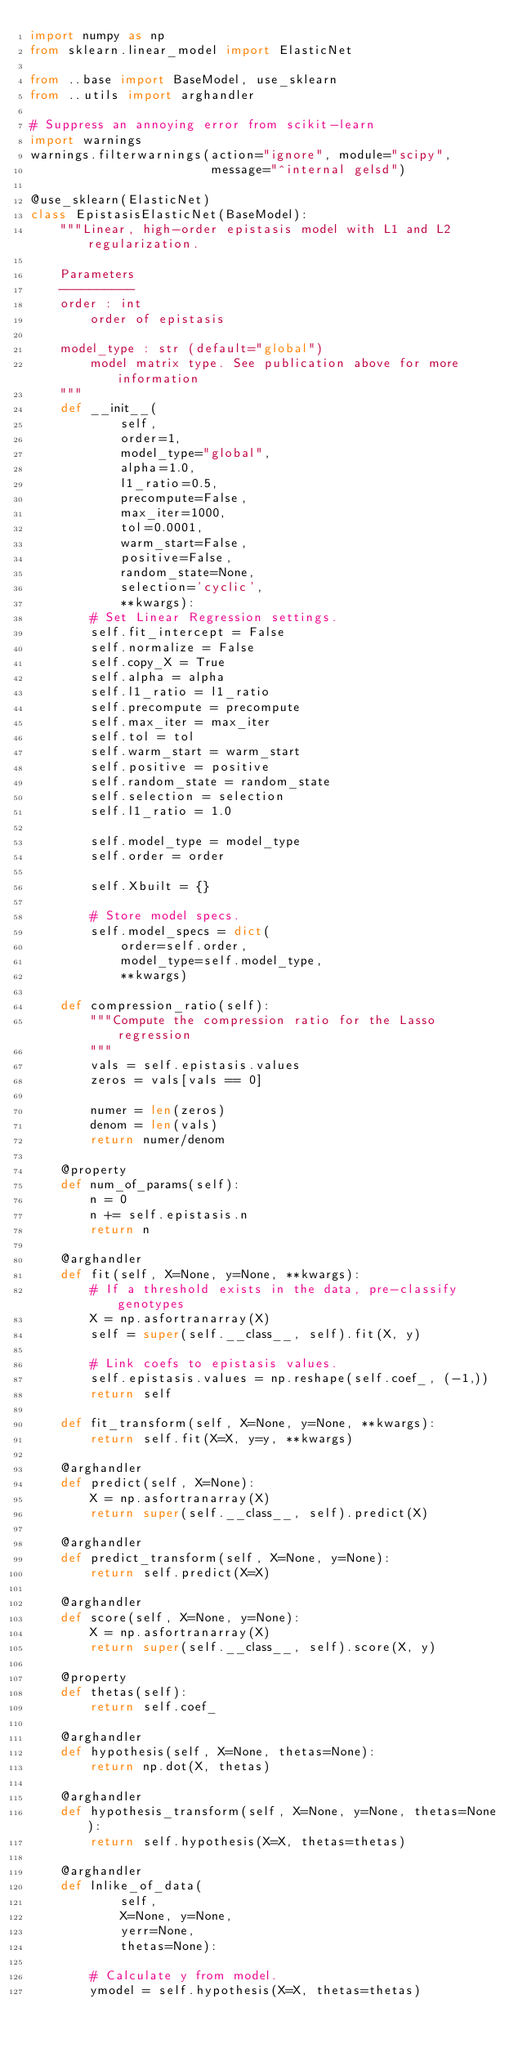<code> <loc_0><loc_0><loc_500><loc_500><_Python_>import numpy as np
from sklearn.linear_model import ElasticNet

from ..base import BaseModel, use_sklearn
from ..utils import arghandler

# Suppress an annoying error from scikit-learn
import warnings
warnings.filterwarnings(action="ignore", module="scipy",
                        message="^internal gelsd")

@use_sklearn(ElasticNet)
class EpistasisElasticNet(BaseModel):
    """Linear, high-order epistasis model with L1 and L2 regularization.

    Parameters
    ----------
    order : int
        order of epistasis

    model_type : str (default="global")
        model matrix type. See publication above for more information
    """
    def __init__(
            self,
            order=1,
            model_type="global",
            alpha=1.0,
            l1_ratio=0.5,
            precompute=False,
            max_iter=1000,
            tol=0.0001,
            warm_start=False,
            positive=False,
            random_state=None,
            selection='cyclic',
            **kwargs):
        # Set Linear Regression settings.
        self.fit_intercept = False
        self.normalize = False
        self.copy_X = True
        self.alpha = alpha
        self.l1_ratio = l1_ratio
        self.precompute = precompute
        self.max_iter = max_iter
        self.tol = tol
        self.warm_start = warm_start
        self.positive = positive
        self.random_state = random_state
        self.selection = selection
        self.l1_ratio = 1.0

        self.model_type = model_type
        self.order = order

        self.Xbuilt = {}

        # Store model specs.
        self.model_specs = dict(
            order=self.order,
            model_type=self.model_type,
            **kwargs)

    def compression_ratio(self):
        """Compute the compression ratio for the Lasso regression
        """
        vals = self.epistasis.values
        zeros = vals[vals == 0]

        numer = len(zeros)
        denom = len(vals)
        return numer/denom

    @property
    def num_of_params(self):
        n = 0
        n += self.epistasis.n
        return n

    @arghandler
    def fit(self, X=None, y=None, **kwargs):
        # If a threshold exists in the data, pre-classify genotypes
        X = np.asfortranarray(X)
        self = super(self.__class__, self).fit(X, y)

        # Link coefs to epistasis values.
        self.epistasis.values = np.reshape(self.coef_, (-1,))
        return self

    def fit_transform(self, X=None, y=None, **kwargs):
        return self.fit(X=X, y=y, **kwargs)

    @arghandler
    def predict(self, X=None):
        X = np.asfortranarray(X)
        return super(self.__class__, self).predict(X)

    @arghandler
    def predict_transform(self, X=None, y=None):
        return self.predict(X=X)

    @arghandler
    def score(self, X=None, y=None):
        X = np.asfortranarray(X)
        return super(self.__class__, self).score(X, y)

    @property
    def thetas(self):
        return self.coef_

    @arghandler
    def hypothesis(self, X=None, thetas=None):
        return np.dot(X, thetas)

    @arghandler
    def hypothesis_transform(self, X=None, y=None, thetas=None):
        return self.hypothesis(X=X, thetas=thetas)

    @arghandler
    def lnlike_of_data(
            self,
            X=None, y=None,
            yerr=None,
            thetas=None):

        # Calculate y from model.
        ymodel = self.hypothesis(X=X, thetas=thetas)
</code> 